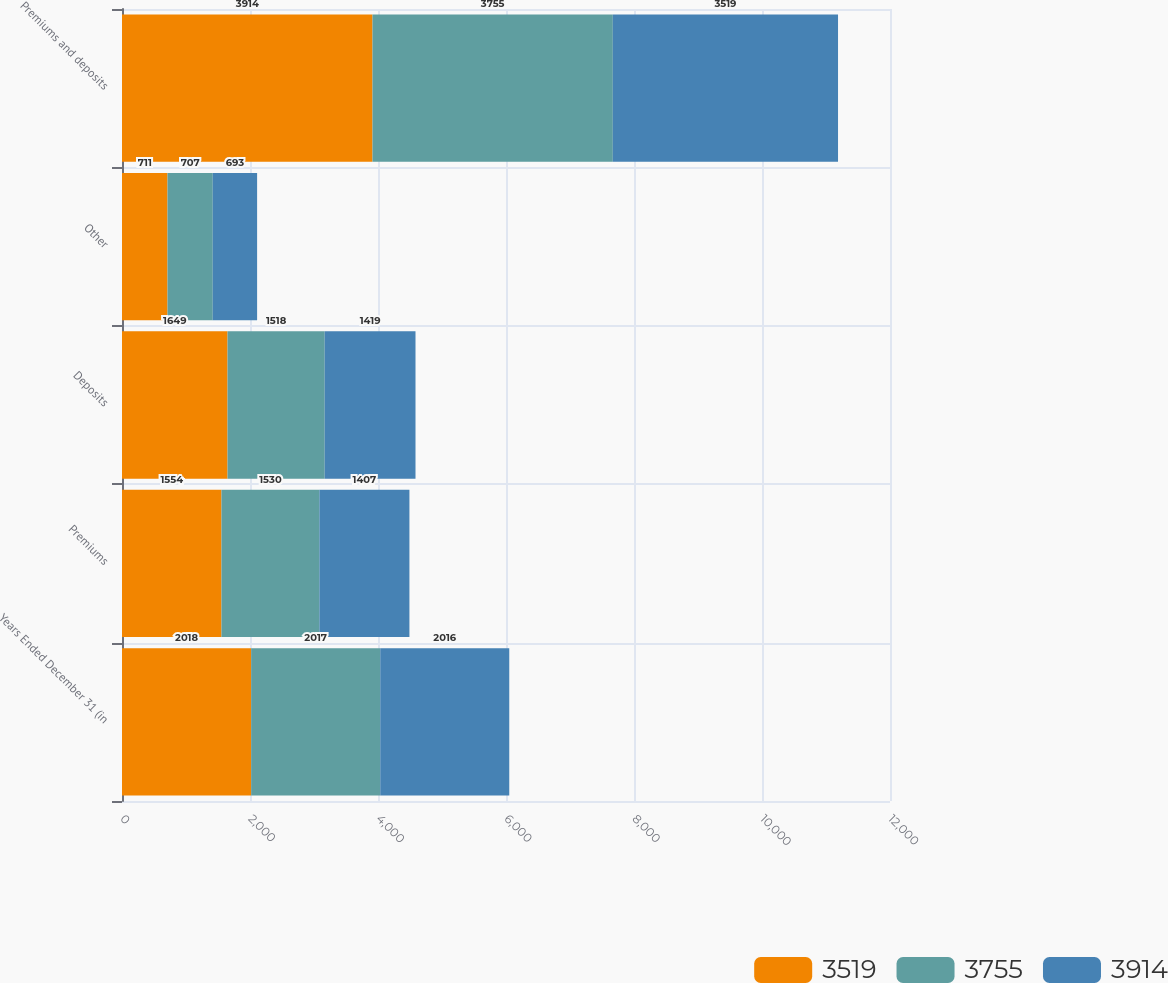Convert chart to OTSL. <chart><loc_0><loc_0><loc_500><loc_500><stacked_bar_chart><ecel><fcel>Years Ended December 31 (in<fcel>Premiums<fcel>Deposits<fcel>Other<fcel>Premiums and deposits<nl><fcel>3519<fcel>2018<fcel>1554<fcel>1649<fcel>711<fcel>3914<nl><fcel>3755<fcel>2017<fcel>1530<fcel>1518<fcel>707<fcel>3755<nl><fcel>3914<fcel>2016<fcel>1407<fcel>1419<fcel>693<fcel>3519<nl></chart> 